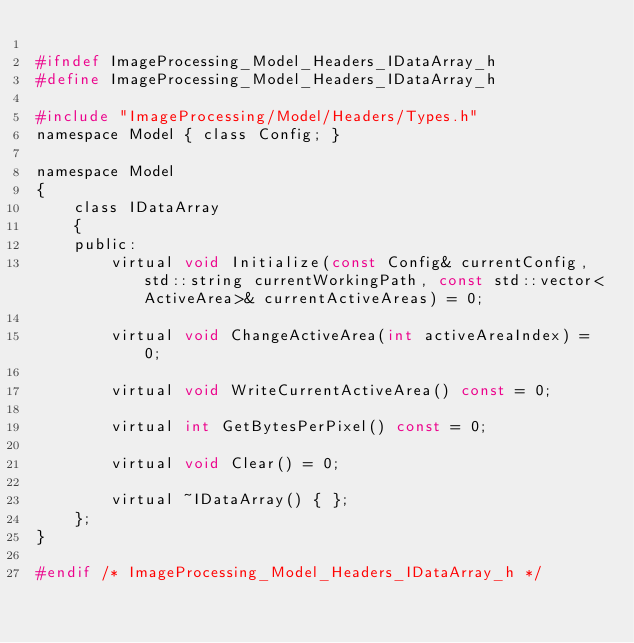<code> <loc_0><loc_0><loc_500><loc_500><_C_>
#ifndef ImageProcessing_Model_Headers_IDataArray_h
#define ImageProcessing_Model_Headers_IDataArray_h

#include "ImageProcessing/Model/Headers/Types.h"
namespace Model { class Config; }

namespace Model
{
    class IDataArray
    {
    public:
        virtual void Initialize(const Config& currentConfig, std::string currentWorkingPath, const std::vector<ActiveArea>& currentActiveAreas) = 0;

        virtual void ChangeActiveArea(int activeAreaIndex) = 0;

        virtual void WriteCurrentActiveArea() const = 0;

        virtual int GetBytesPerPixel() const = 0;

        virtual void Clear() = 0;

        virtual ~IDataArray() { };
    };
}

#endif /* ImageProcessing_Model_Headers_IDataArray_h */

</code> 